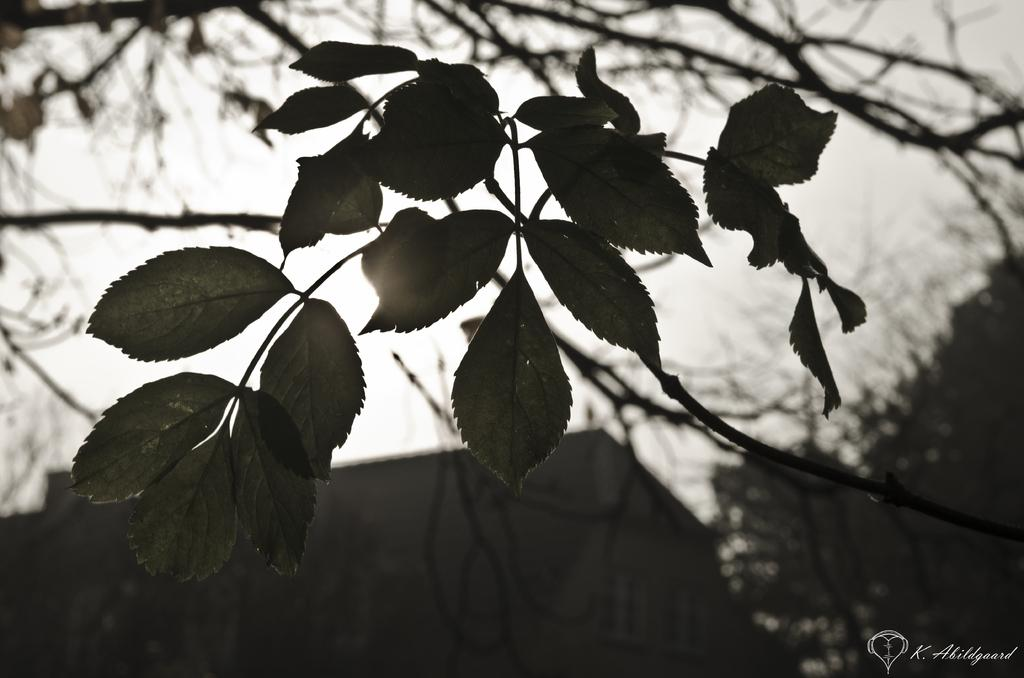What type of structure is present in the image? There is a building in the image. What other natural elements can be seen in the image? There are trees in the image. What part of the environment is visible in the image? The sky is visible in the image. How would you describe the lighting in the image? The image appears to be slightly dark. Can you see any wings on the building in the image? There are no wings visible on the building in the image. What type of test is being conducted in the image? There is no test being conducted in the image; it simply shows a building, trees, and the sky. 